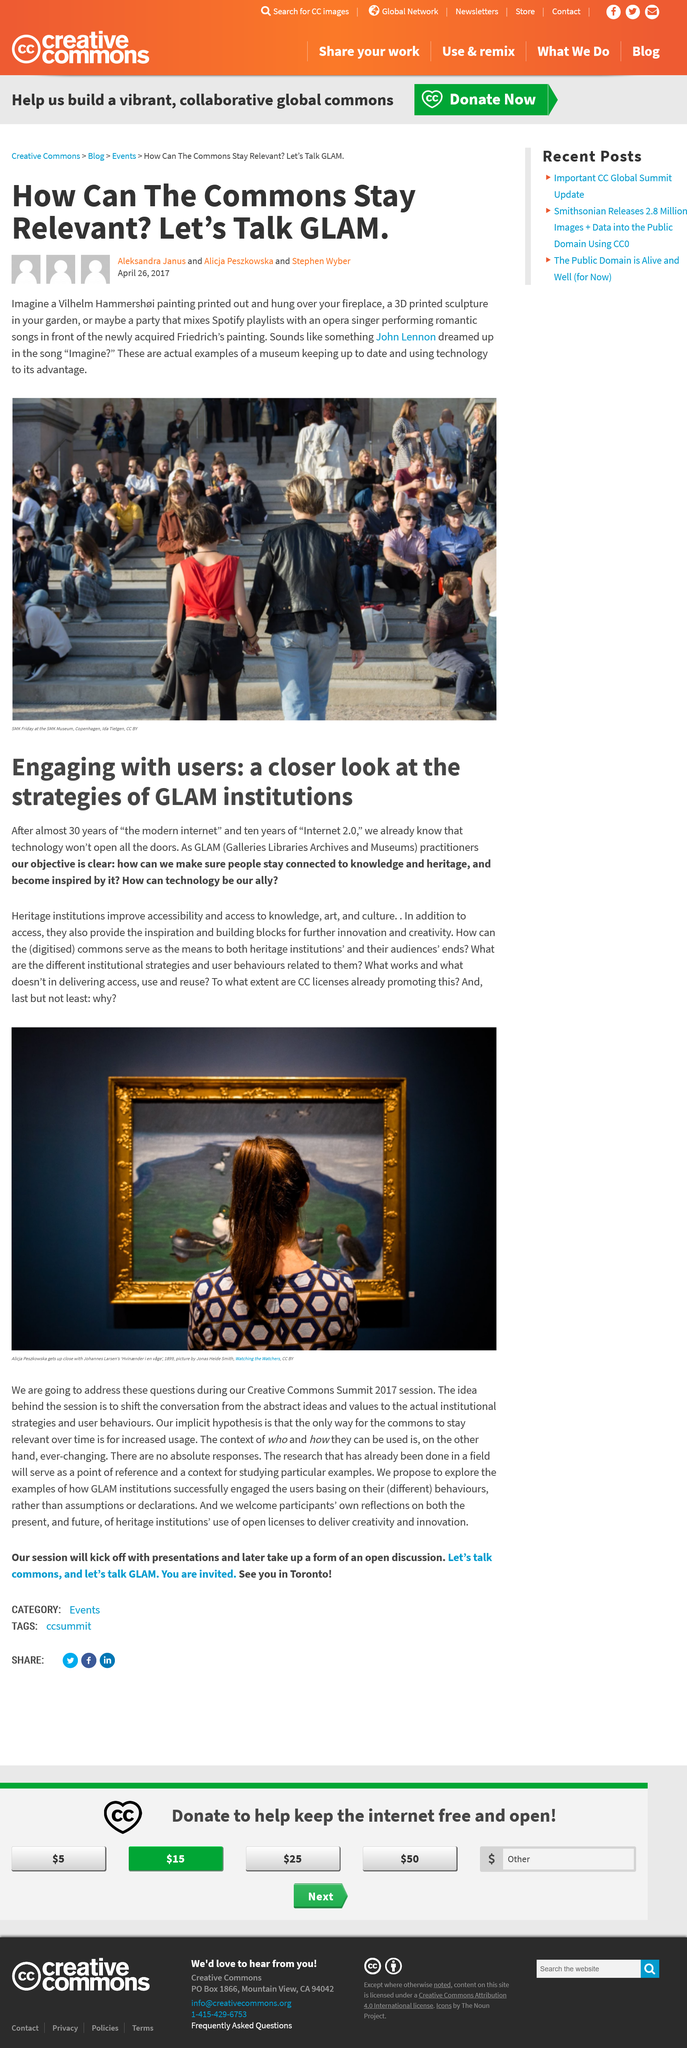Outline some significant characteristics in this image. The acronym GLAM stands for Galleries, Libraries, Archives, and Museums. The John Lennon song 'Imagine' is related to modern-day museums in that it envisions a world without borders or division, much like the way museums aim to bring people together from different cultures and backgrounds to appreciate art and history. The people in the picture are entering a building that is likely a museum, based on the text provided. Three authors wrote about the picture. GLAM institutions are galleries, libraries, archives, and museums that collect, preserve, and make accessible cultural and historical artifacts and knowledge for the public's benefit. 